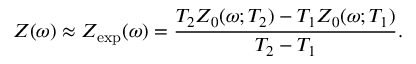<formula> <loc_0><loc_0><loc_500><loc_500>Z ( \omega ) \approx Z _ { e x p } ( \omega ) = \frac { T _ { 2 } Z _ { 0 } ( \omega ; T _ { 2 } ) - T _ { 1 } Z _ { 0 } ( \omega ; T _ { 1 } ) } { T _ { 2 } - T _ { 1 } } .</formula> 